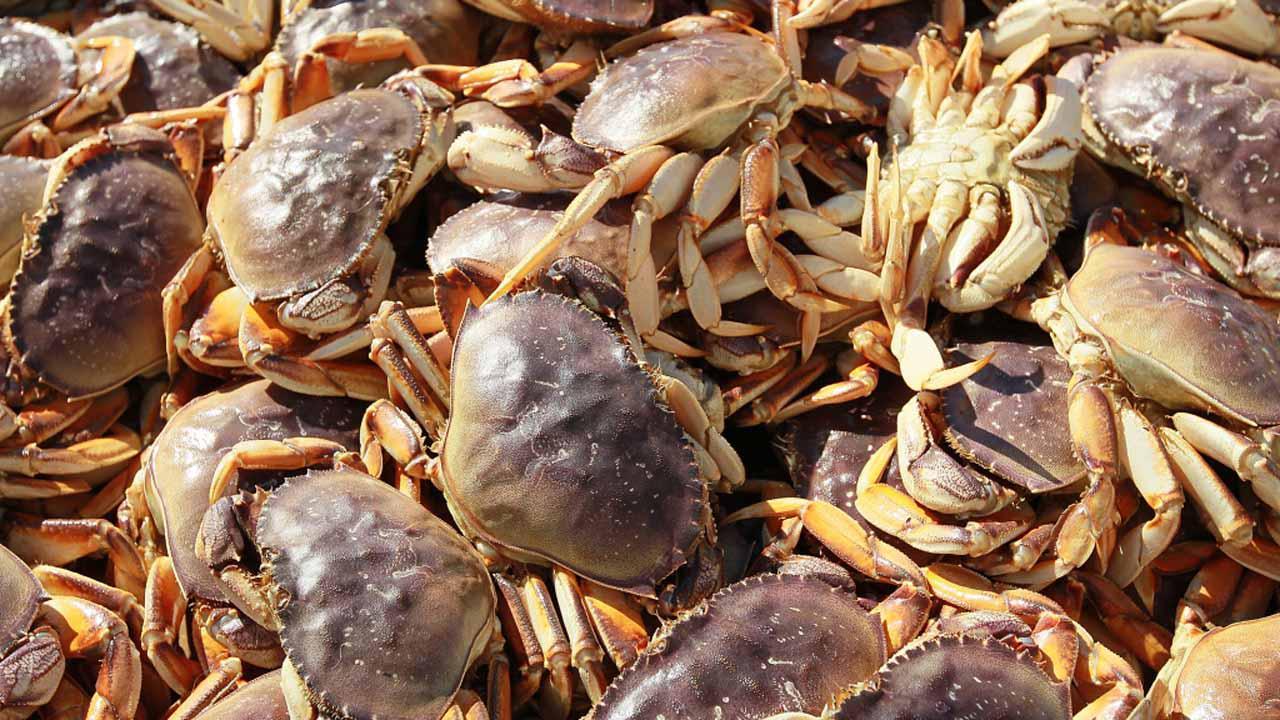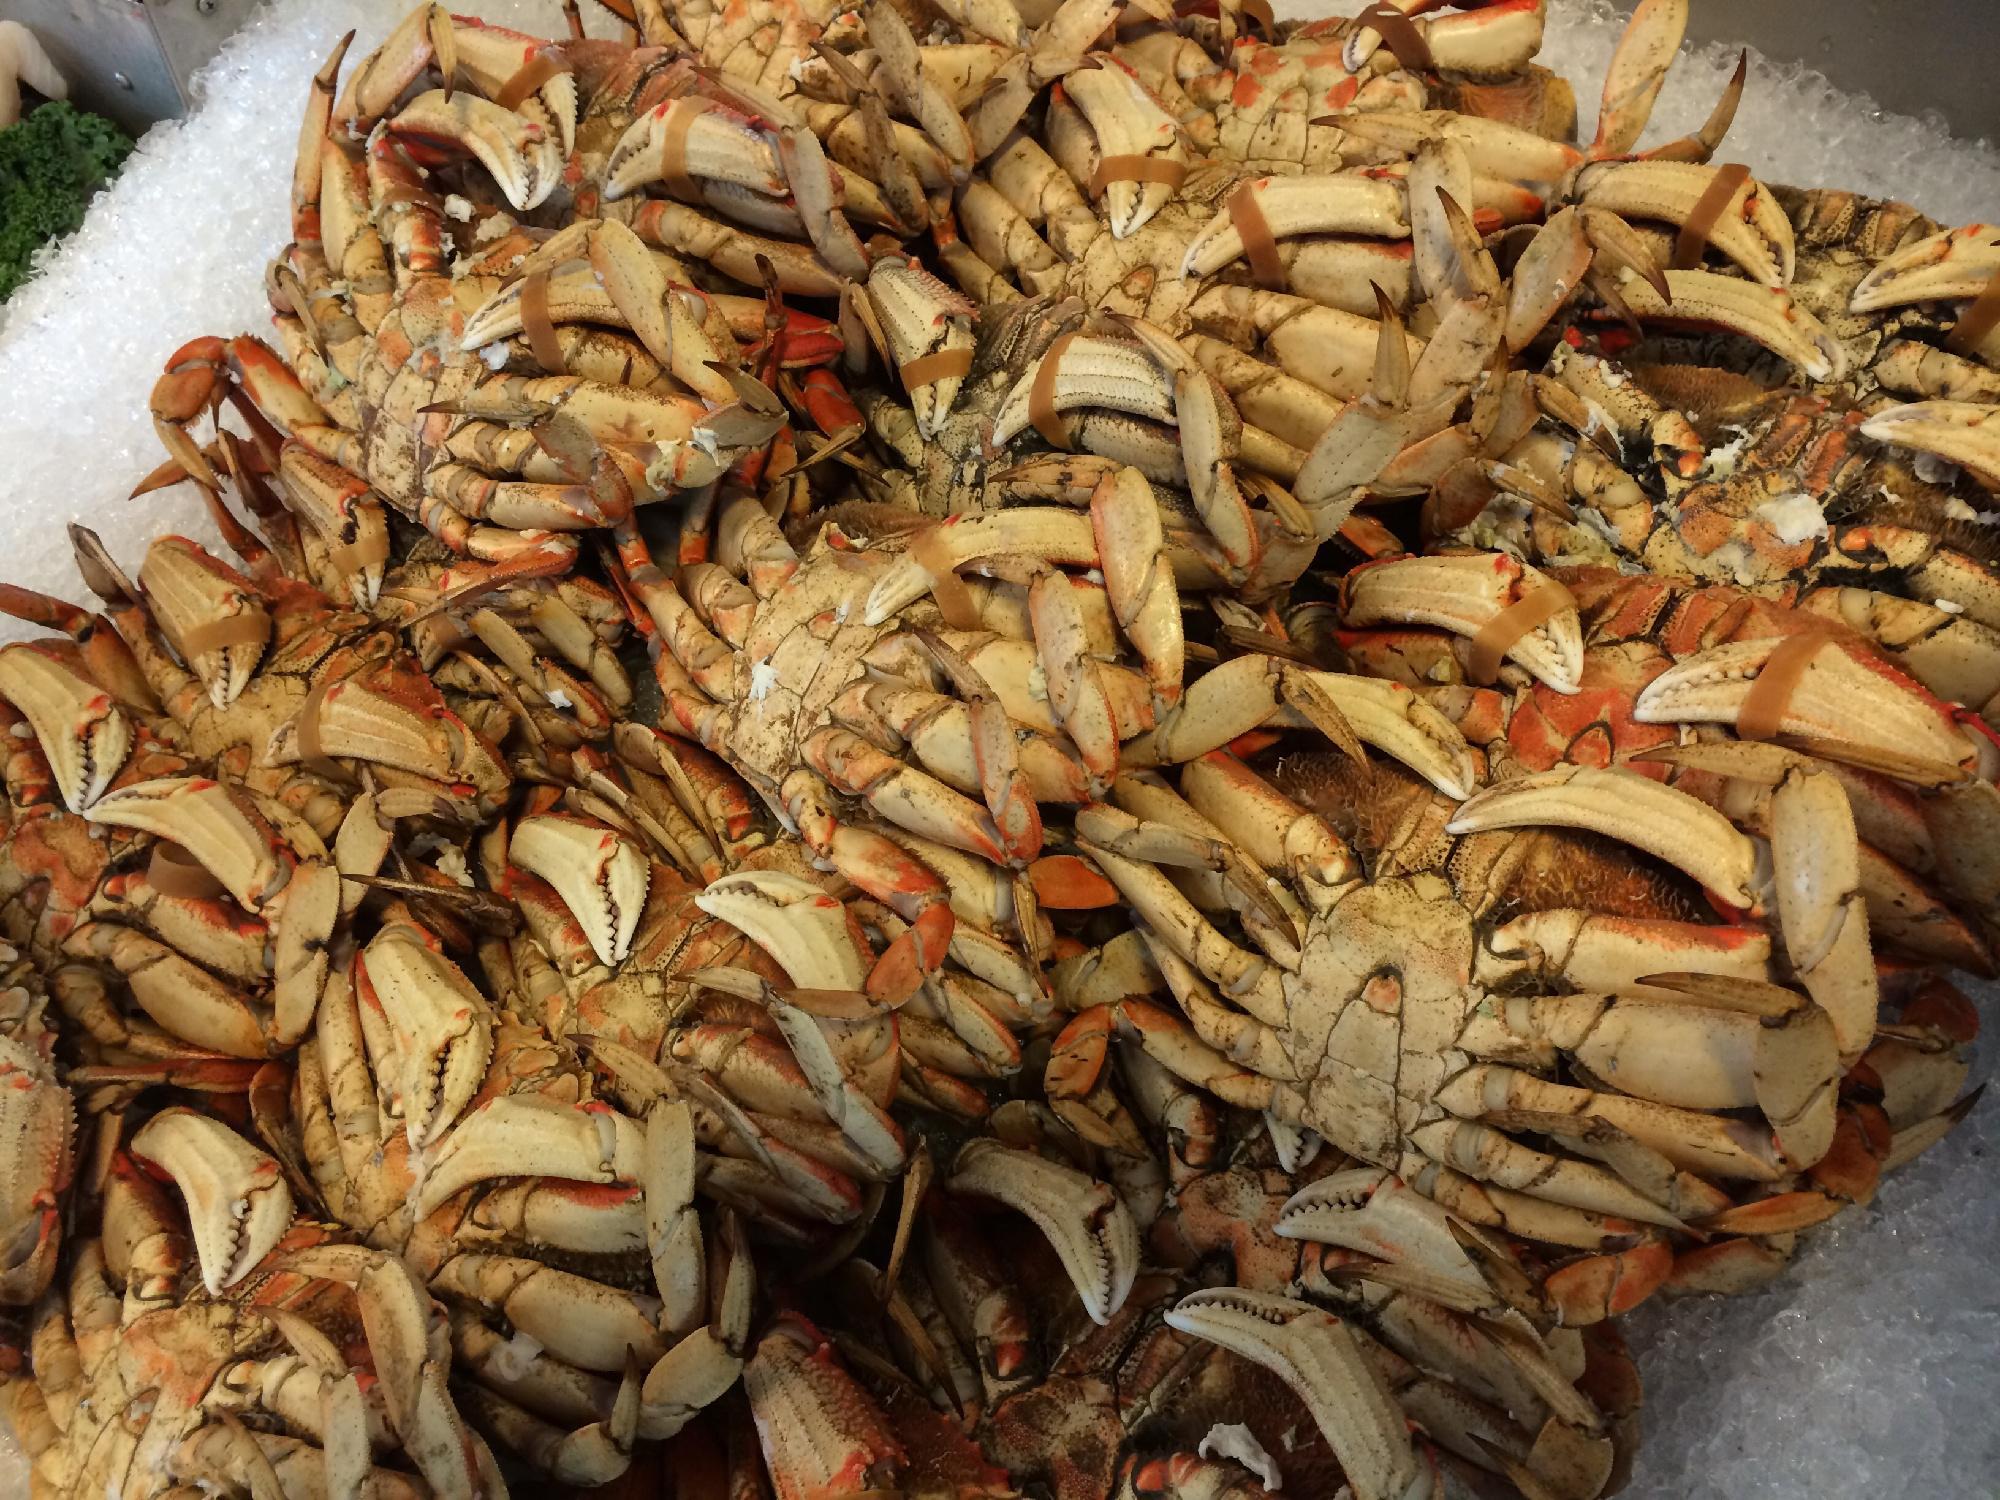The first image is the image on the left, the second image is the image on the right. Analyze the images presented: Is the assertion "The crabs in the left image are mostly brown in color; they are not tinted red." valid? Answer yes or no. Yes. 